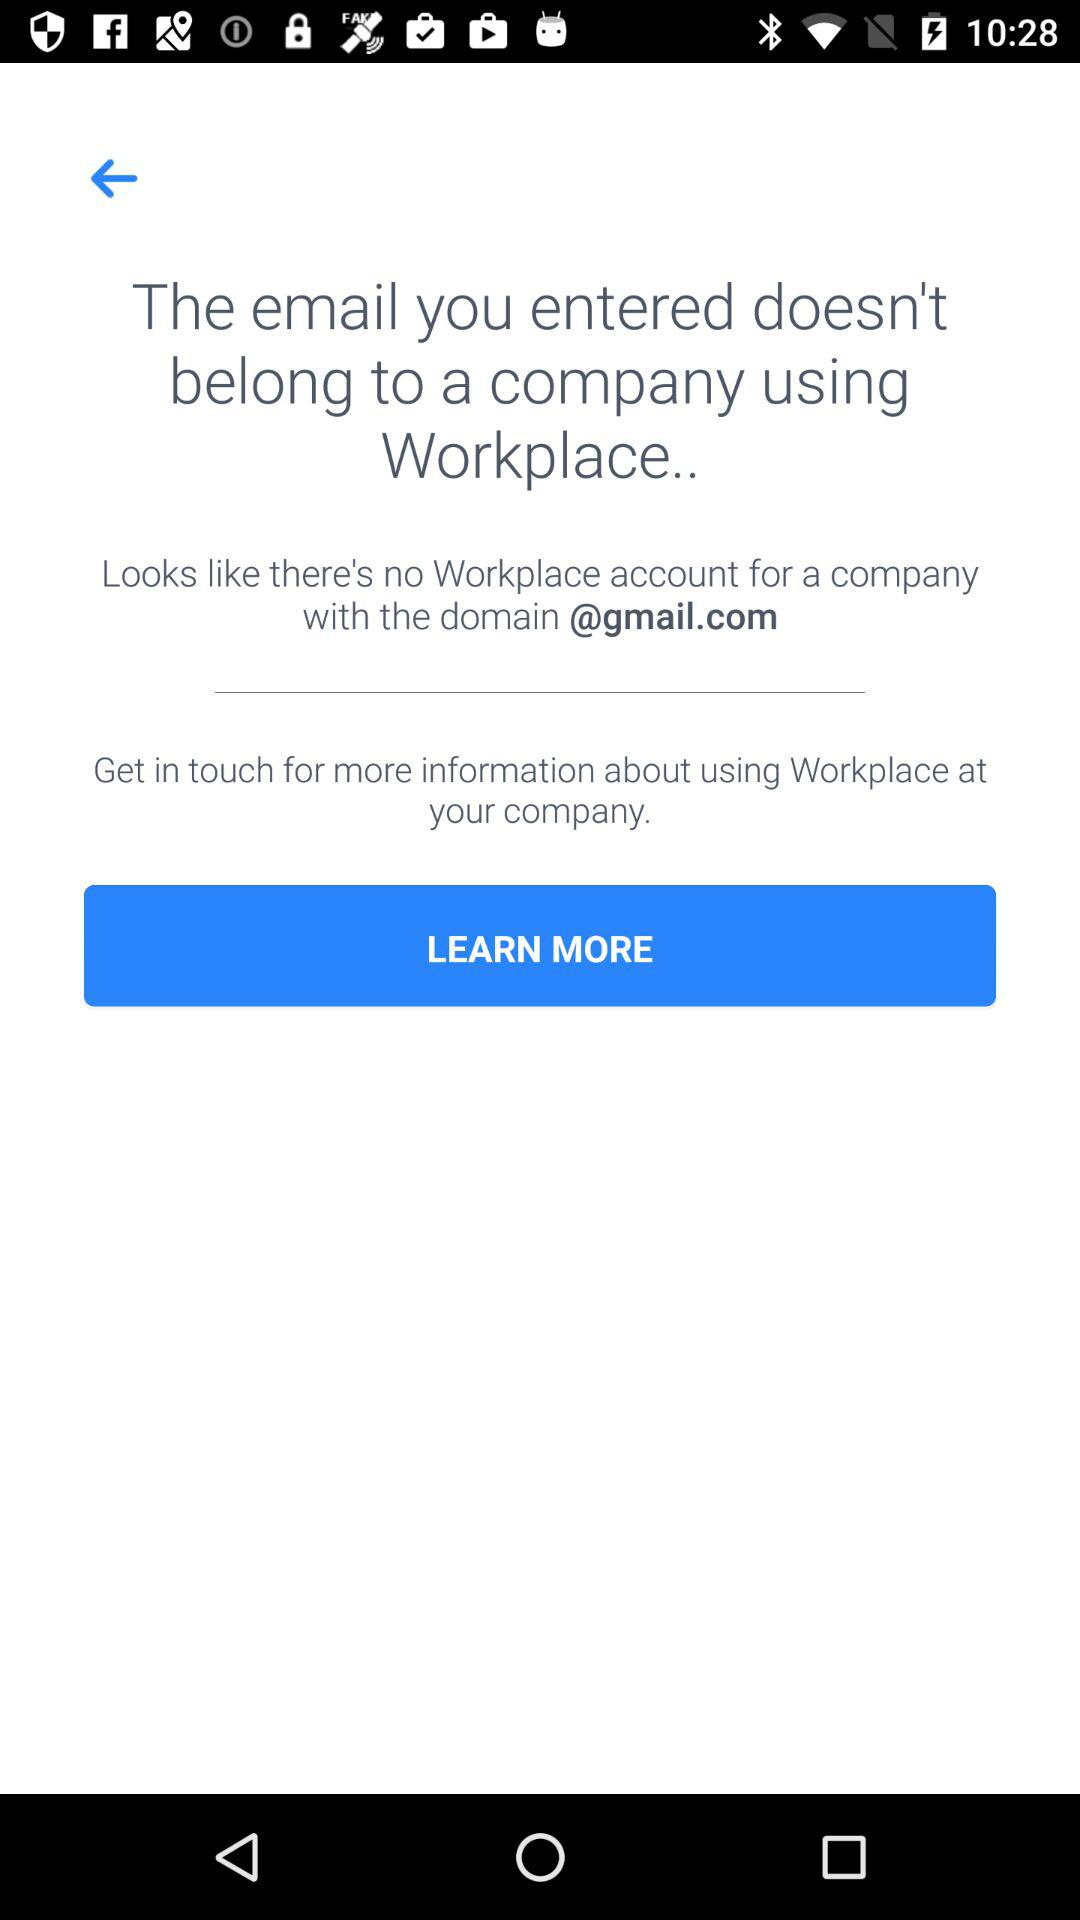What is the domain? The domain is @gmail.com. 